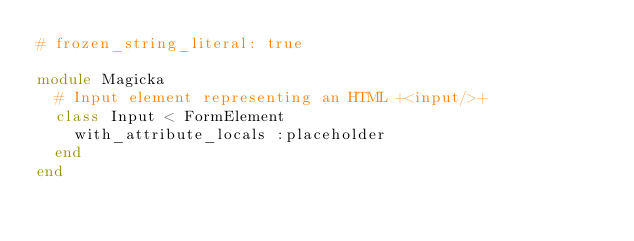<code> <loc_0><loc_0><loc_500><loc_500><_Ruby_># frozen_string_literal: true

module Magicka
  # Input element representing an HTML +<input/>+
  class Input < FormElement
    with_attribute_locals :placeholder
  end
end
</code> 